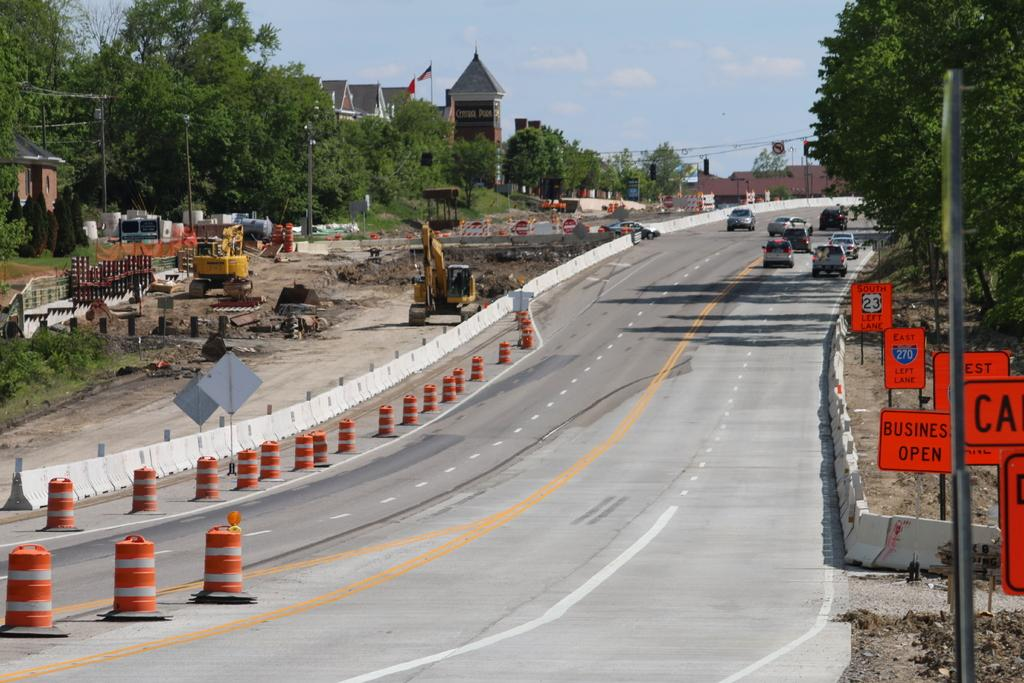Provide a one-sentence caption for the provided image. Street with a sign which says Business open in orange. 